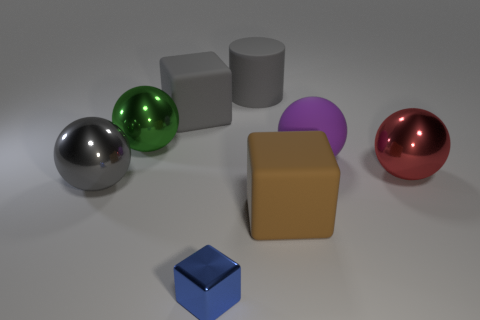Are there any things on the left side of the purple rubber ball?
Your response must be concise. Yes. There is a big metallic thing behind the purple ball; are there any metal things that are right of it?
Give a very brief answer. Yes. Is the number of big gray blocks that are to the right of the red metallic thing less than the number of spheres that are in front of the green shiny ball?
Make the answer very short. Yes. Is there anything else that is the same size as the blue metallic thing?
Your answer should be very brief. No. The large green metallic thing has what shape?
Make the answer very short. Sphere. What is the material of the block in front of the large brown block?
Make the answer very short. Metal. How big is the blue object that is on the left side of the matte cube that is in front of the large rubber object to the left of the small object?
Your answer should be compact. Small. Is the material of the gray thing that is behind the big gray rubber cube the same as the cube behind the big brown rubber cube?
Offer a very short reply. Yes. What number of other objects are the same color as the small metal object?
Your answer should be compact. 0. How many things are either shiny things on the right side of the blue object or large rubber blocks on the right side of the blue metallic block?
Your answer should be compact. 2. 